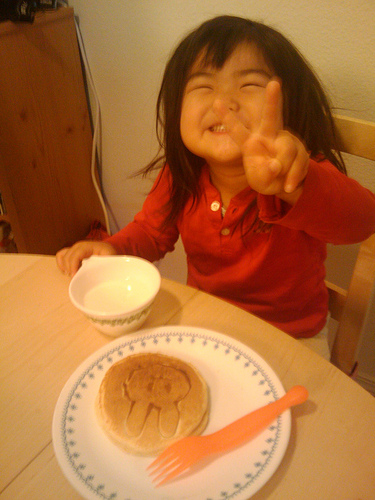<image>
Is the girl to the left of the chair? No. The girl is not to the left of the chair. From this viewpoint, they have a different horizontal relationship. Where is the food in relation to the baby? Is it behind the baby? No. The food is not behind the baby. From this viewpoint, the food appears to be positioned elsewhere in the scene. 